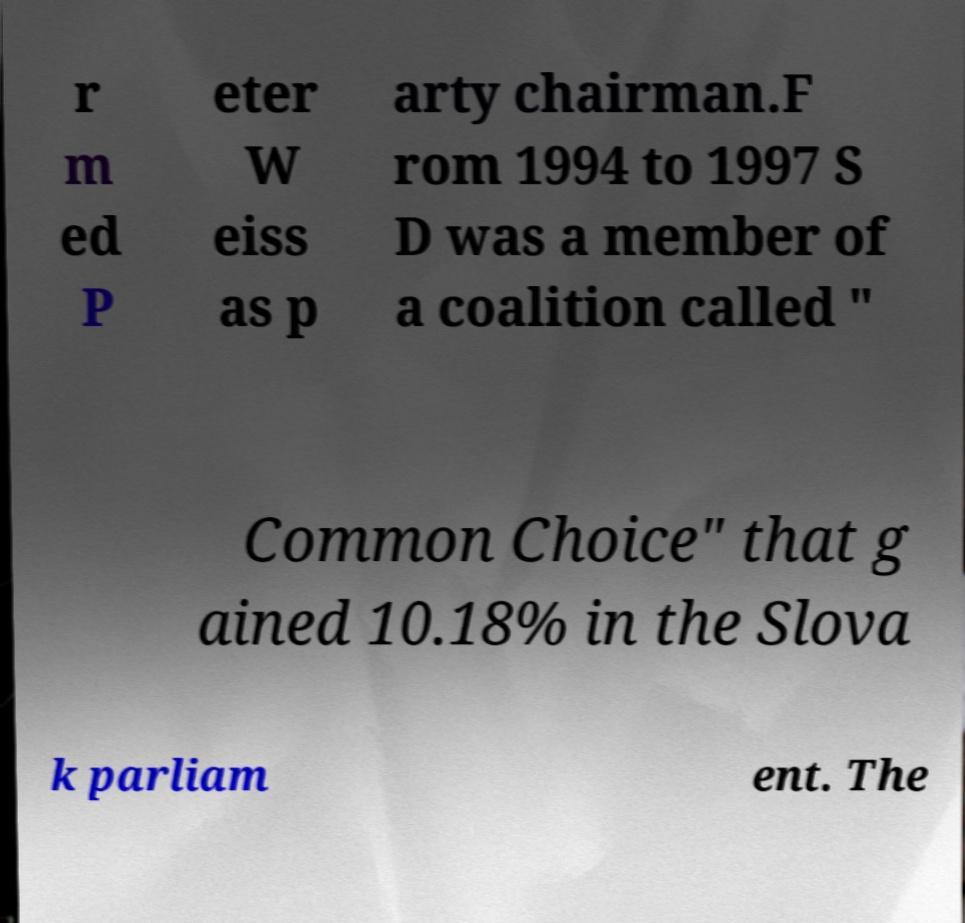Can you read and provide the text displayed in the image?This photo seems to have some interesting text. Can you extract and type it out for me? r m ed P eter W eiss as p arty chairman.F rom 1994 to 1997 S D was a member of a coalition called " Common Choice" that g ained 10.18% in the Slova k parliam ent. The 